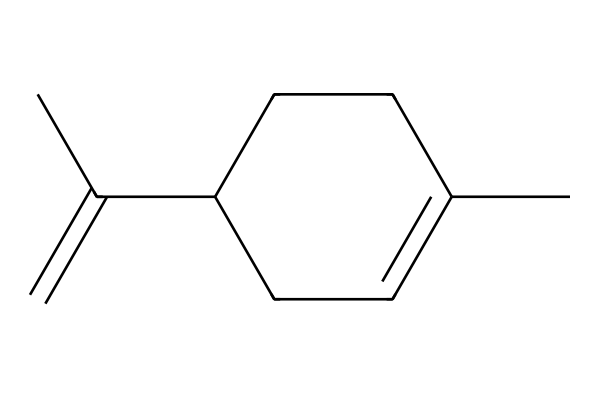What is the total number of carbon atoms in limonene? Counting the 'C' in the SMILES representation shows there are 10 carbon atoms in total.
Answer: 10 How many double bonds does limonene contain? In the SMILES representation, there is one double bond indicated by the '=' sign.
Answer: 1 What type of compound is limonene classified as? Looking at the structure, limonene qualifies as a cyclic terpene due to its ring formation and presence of double bonds.
Answer: cyclic terpene What is the degree of unsaturation for limonene? The degree of unsaturation is calculated using the formula: (2C + 2 - H)/2. For limonene, substituting in C=10 and H=16 yields a degree of unsaturation of 2.
Answer: 2 Is limonene a saturated or unsaturated compound? The presence of a double bond in the structure suggests that limonene is an unsaturated compound.
Answer: unsaturated Which part of the limonene structure creates its characteristic citrus aroma? The specific arrangement of the double bond, along with the cyclic structure, contributes to its characteristic citrus aroma as a terpene.
Answer: double bond What functional groups are present in limonene? The chemical structure contains no additional functional groups besides the alkene (due to the double bond) in its cyclic framework.
Answer: alkene 